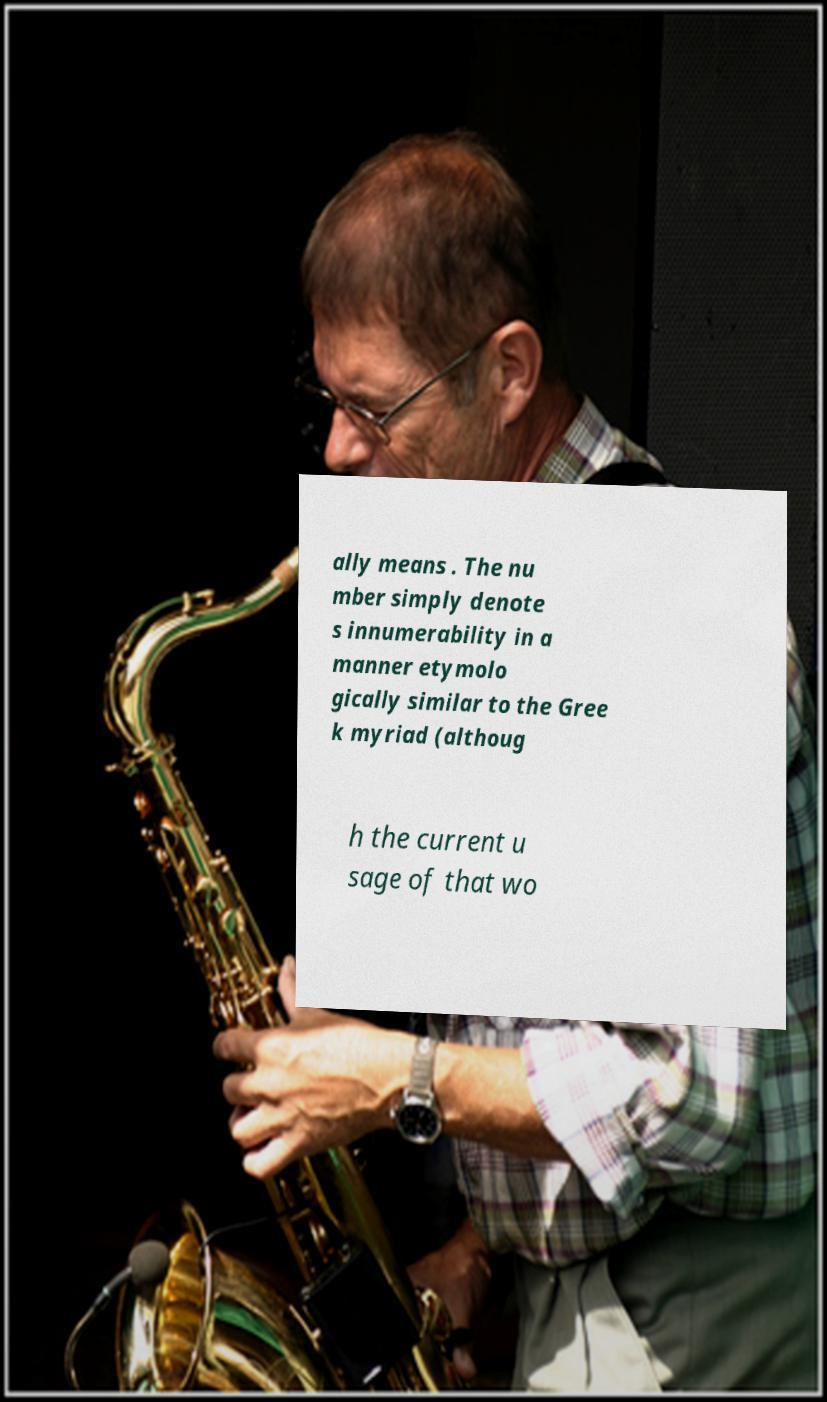Please read and relay the text visible in this image. What does it say? ally means . The nu mber simply denote s innumerability in a manner etymolo gically similar to the Gree k myriad (althoug h the current u sage of that wo 